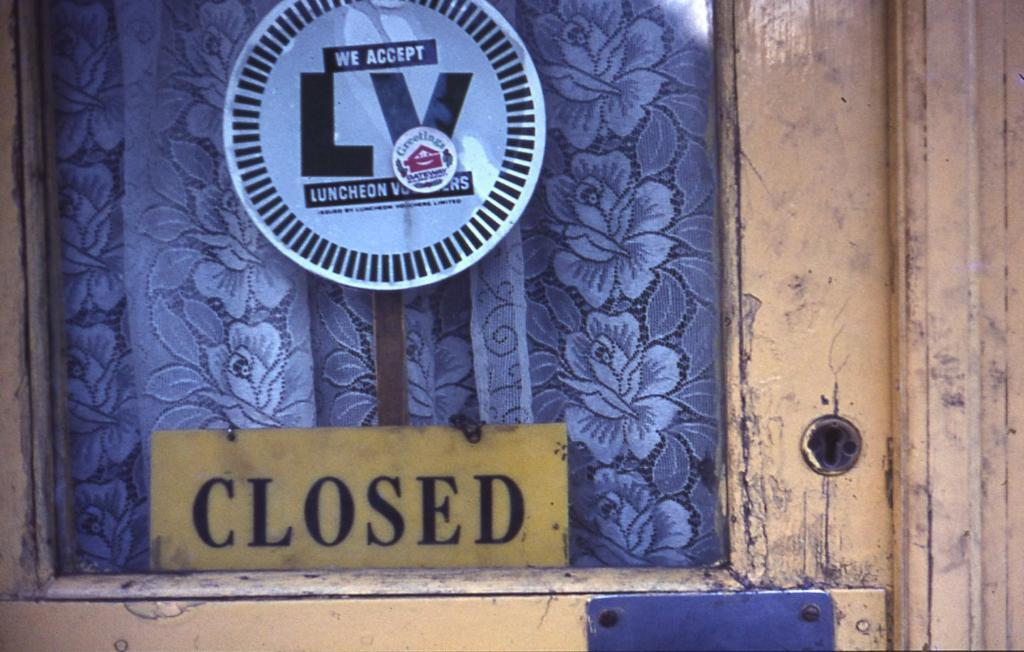<image>
Create a compact narrative representing the image presented. A yellow wooden door with a closed sign at the bottom of the glass. 